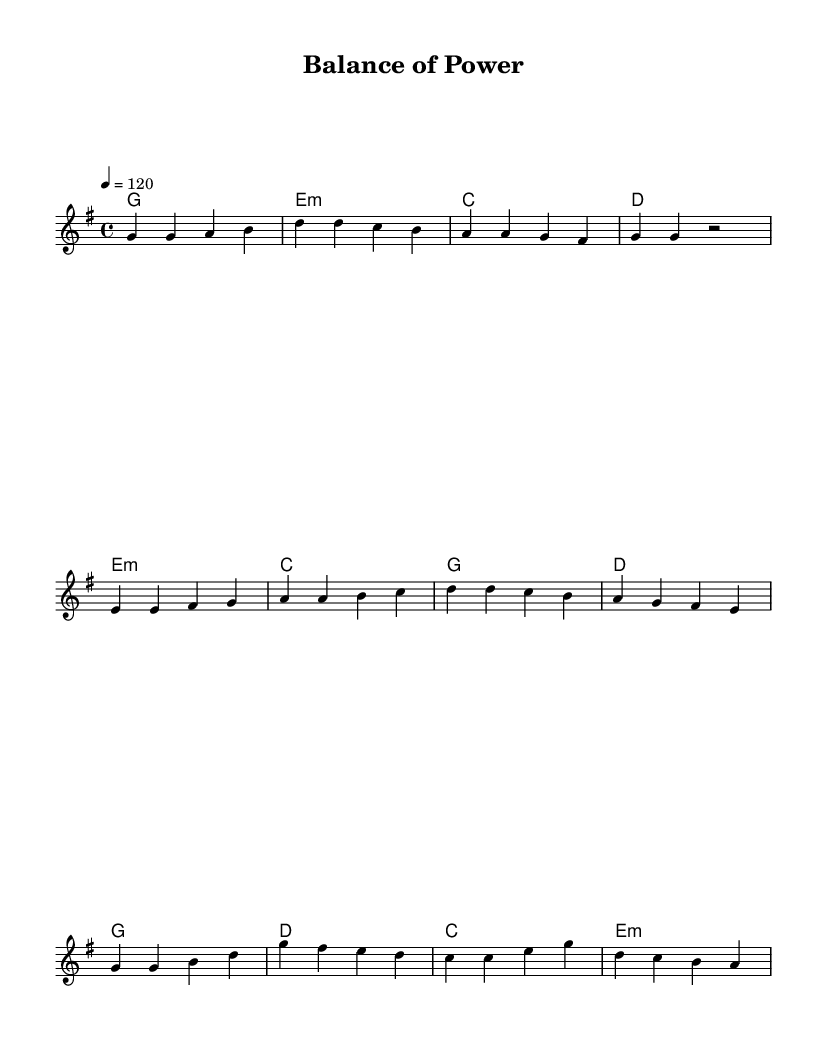What is the key signature of this music? The key signature is G major, as indicated by the one sharps (F#) present in the key signature at the beginning of the staff.
Answer: G major What is the time signature of this music? The time signature is 4/4, which means there are four beats in every measure and a quarter note gets one beat. This is indicated at the beginning of the score.
Answer: 4/4 What is the tempo marking of the piece? The tempo marking is 120 beats per minute, indicated by the number "120" following the tempo text "4 =". This indicates the speed of the music.
Answer: 120 How many measures are in the chorus section? The chorus section contains four measures, as evident in the notation provided, where each four-bar sequence indicates a full measure of time in 4/4 time.
Answer: 4 What chords are used in the verse? The chords used in the verse are G, Em, C, and D, as indicated in the chord names provided above the melody for the verse section.
Answer: G, Em, C, D Which musical section features a pre-chorus? The section that features a pre-chorus is the one labeled "Pre-Chorus," which follows the verse section and leads into the chorus with its own distinct melody and chord progression.
Answer: Pre-Chorus How does the melody of the pre-chorus differ from the verse? The melody of the pre-chorus generally features a rise in pitch and introduces new notes (e.g., e, fis, g) that do not appear in the verse, showing a shift in musical dynamics.
Answer: Higher notes 